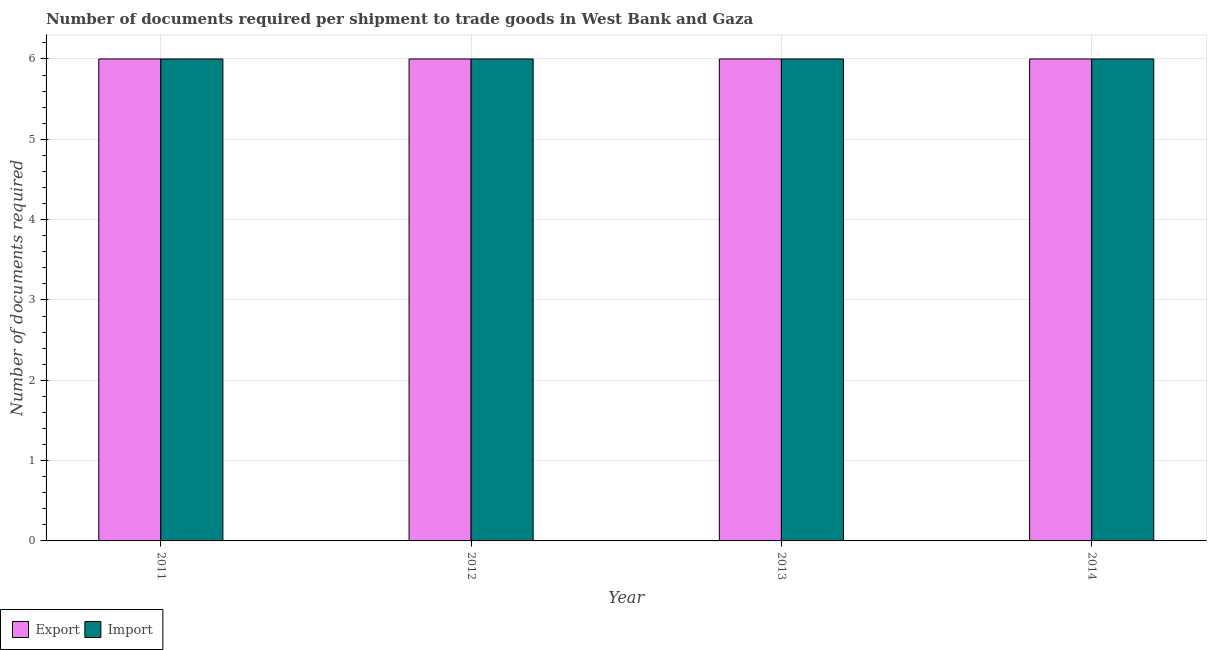How many different coloured bars are there?
Give a very brief answer. 2. How many groups of bars are there?
Give a very brief answer. 4. Are the number of bars per tick equal to the number of legend labels?
Ensure brevity in your answer.  Yes. Are the number of bars on each tick of the X-axis equal?
Keep it short and to the point. Yes. How many bars are there on the 4th tick from the left?
Keep it short and to the point. 2. How many bars are there on the 2nd tick from the right?
Give a very brief answer. 2. What is the number of documents required to export goods in 2014?
Provide a short and direct response. 6. Across all years, what is the minimum number of documents required to export goods?
Offer a very short reply. 6. In which year was the number of documents required to import goods maximum?
Your response must be concise. 2011. What is the total number of documents required to export goods in the graph?
Offer a terse response. 24. What is the difference between the number of documents required to import goods in 2011 and that in 2014?
Give a very brief answer. 0. What is the difference between the number of documents required to export goods in 2013 and the number of documents required to import goods in 2012?
Your answer should be compact. 0. What is the average number of documents required to export goods per year?
Provide a succinct answer. 6. In the year 2014, what is the difference between the number of documents required to export goods and number of documents required to import goods?
Provide a short and direct response. 0. In how many years, is the number of documents required to export goods greater than 3.4?
Your answer should be very brief. 4. Is the number of documents required to export goods in 2011 less than that in 2013?
Make the answer very short. No. Is the difference between the number of documents required to import goods in 2011 and 2012 greater than the difference between the number of documents required to export goods in 2011 and 2012?
Make the answer very short. No. What does the 2nd bar from the left in 2011 represents?
Keep it short and to the point. Import. What does the 1st bar from the right in 2014 represents?
Ensure brevity in your answer.  Import. Are all the bars in the graph horizontal?
Your answer should be compact. No. How many years are there in the graph?
Provide a succinct answer. 4. What is the difference between two consecutive major ticks on the Y-axis?
Offer a terse response. 1. Are the values on the major ticks of Y-axis written in scientific E-notation?
Give a very brief answer. No. Does the graph contain any zero values?
Keep it short and to the point. No. Does the graph contain grids?
Ensure brevity in your answer.  Yes. How many legend labels are there?
Give a very brief answer. 2. What is the title of the graph?
Make the answer very short. Number of documents required per shipment to trade goods in West Bank and Gaza. What is the label or title of the Y-axis?
Give a very brief answer. Number of documents required. What is the Number of documents required in Export in 2011?
Make the answer very short. 6. What is the Number of documents required in Export in 2014?
Offer a terse response. 6. What is the Number of documents required of Import in 2014?
Your response must be concise. 6. Across all years, what is the maximum Number of documents required in Export?
Make the answer very short. 6. What is the total Number of documents required of Export in the graph?
Provide a succinct answer. 24. What is the total Number of documents required in Import in the graph?
Your answer should be compact. 24. What is the difference between the Number of documents required of Export in 2011 and that in 2014?
Provide a succinct answer. 0. What is the difference between the Number of documents required in Import in 2011 and that in 2014?
Keep it short and to the point. 0. What is the difference between the Number of documents required of Import in 2012 and that in 2013?
Keep it short and to the point. 0. What is the difference between the Number of documents required of Export in 2012 and that in 2014?
Offer a very short reply. 0. What is the difference between the Number of documents required in Import in 2012 and that in 2014?
Provide a succinct answer. 0. What is the difference between the Number of documents required in Export in 2011 and the Number of documents required in Import in 2013?
Your response must be concise. 0. What is the difference between the Number of documents required in Export in 2011 and the Number of documents required in Import in 2014?
Your answer should be compact. 0. What is the difference between the Number of documents required in Export in 2012 and the Number of documents required in Import in 2013?
Your answer should be very brief. 0. What is the difference between the Number of documents required of Export in 2012 and the Number of documents required of Import in 2014?
Your response must be concise. 0. In the year 2011, what is the difference between the Number of documents required in Export and Number of documents required in Import?
Give a very brief answer. 0. In the year 2014, what is the difference between the Number of documents required in Export and Number of documents required in Import?
Provide a short and direct response. 0. What is the ratio of the Number of documents required of Export in 2011 to that in 2012?
Keep it short and to the point. 1. What is the ratio of the Number of documents required in Export in 2011 to that in 2013?
Offer a very short reply. 1. What is the ratio of the Number of documents required of Export in 2011 to that in 2014?
Make the answer very short. 1. What is the ratio of the Number of documents required in Import in 2011 to that in 2014?
Make the answer very short. 1. What is the ratio of the Number of documents required of Export in 2012 to that in 2013?
Offer a terse response. 1. What is the ratio of the Number of documents required in Import in 2012 to that in 2013?
Keep it short and to the point. 1. What is the ratio of the Number of documents required of Export in 2012 to that in 2014?
Offer a very short reply. 1. What is the ratio of the Number of documents required of Import in 2012 to that in 2014?
Offer a terse response. 1. What is the ratio of the Number of documents required of Export in 2013 to that in 2014?
Provide a short and direct response. 1. What is the difference between the highest and the second highest Number of documents required of Import?
Your answer should be very brief. 0. 